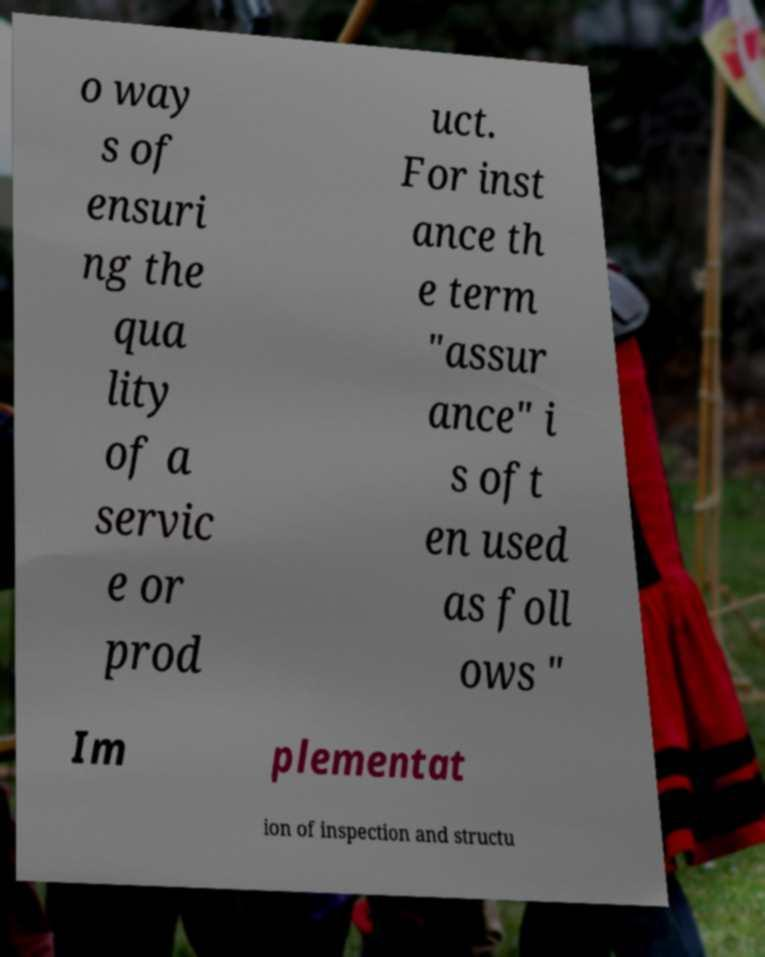Can you read and provide the text displayed in the image?This photo seems to have some interesting text. Can you extract and type it out for me? o way s of ensuri ng the qua lity of a servic e or prod uct. For inst ance th e term "assur ance" i s oft en used as foll ows " Im plementat ion of inspection and structu 